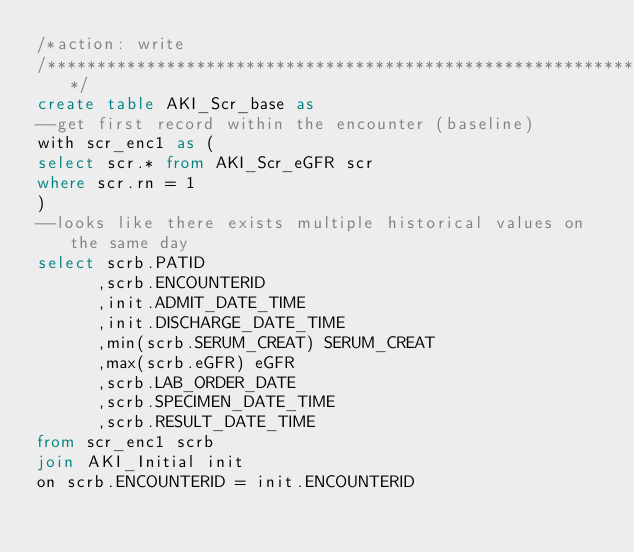<code> <loc_0><loc_0><loc_500><loc_500><_SQL_>/*action: write
/********************************************************************************/
create table AKI_Scr_base as
--get first record within the encounter (baseline)
with scr_enc1 as (
select scr.* from AKI_Scr_eGFR scr
where scr.rn = 1
)
--looks like there exists multiple historical values on the same day 
select scrb.PATID
      ,scrb.ENCOUNTERID
      ,init.ADMIT_DATE_TIME
      ,init.DISCHARGE_DATE_TIME
      ,min(scrb.SERUM_CREAT) SERUM_CREAT
      ,max(scrb.eGFR) eGFR
      ,scrb.LAB_ORDER_DATE
      ,scrb.SPECIMEN_DATE_TIME
      ,scrb.RESULT_DATE_TIME
from scr_enc1 scrb
join AKI_Initial init
on scrb.ENCOUNTERID = init.ENCOUNTERID</code> 